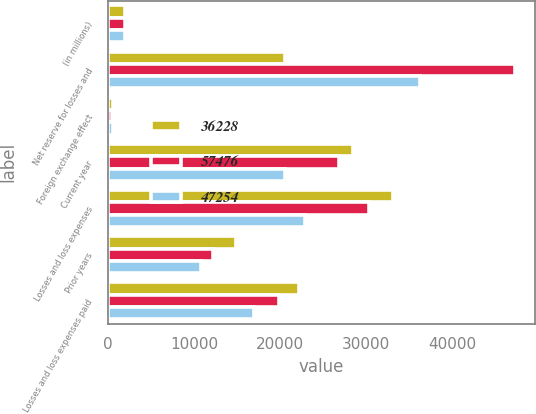Convert chart to OTSL. <chart><loc_0><loc_0><loc_500><loc_500><stacked_bar_chart><ecel><fcel>(in millions)<fcel>Net reserve for losses and<fcel>Foreign exchange effect<fcel>Current year<fcel>Losses and loss expenses<fcel>Prior years<fcel>Losses and loss expenses paid<nl><fcel>36228<fcel>2005<fcel>20509<fcel>628<fcel>28426<fcel>33091<fcel>14910<fcel>22241<nl><fcel>57476<fcel>2004<fcel>47254<fcel>524<fcel>26793<fcel>30357<fcel>12163<fcel>19855<nl><fcel>47254<fcel>2003<fcel>36228<fcel>580<fcel>20509<fcel>22872<fcel>10775<fcel>16962<nl></chart> 